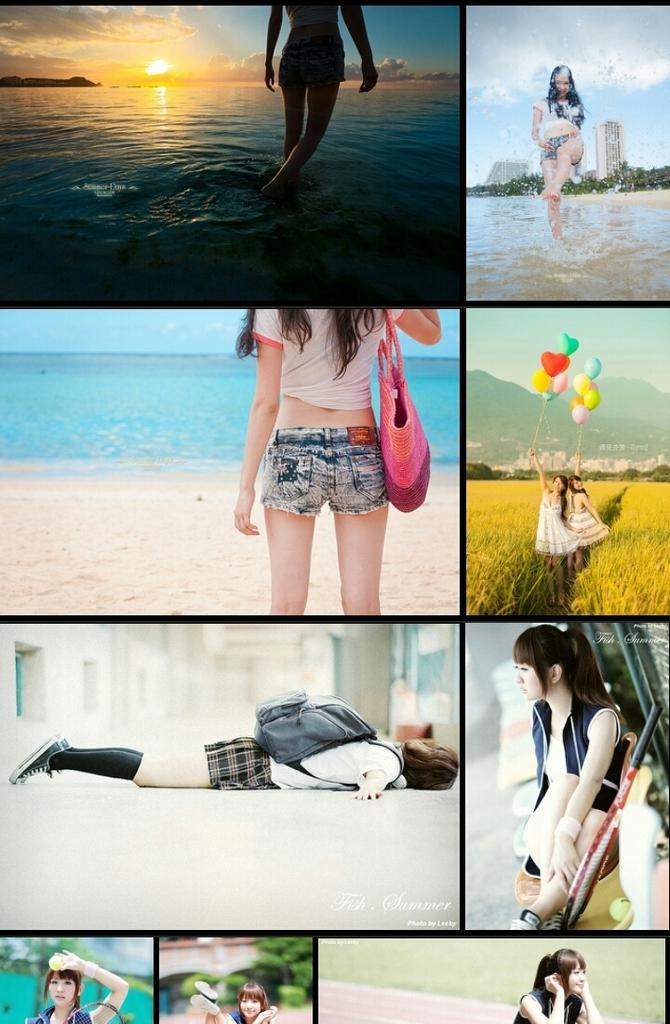Who is the main subject in the image? There is a girl in the image. What is the background of the image? The girl is standing in front of a beach. How is the girl positioned in the image? In some images, the girl is standing, and in others, she is laying down. What might the girl be holding in the image? In some images, the girl is holding balloons. What type of experience does the fireman have with yarn in the image? There is no fireman or yarn present in the image; it features a girl in front of a beach. 